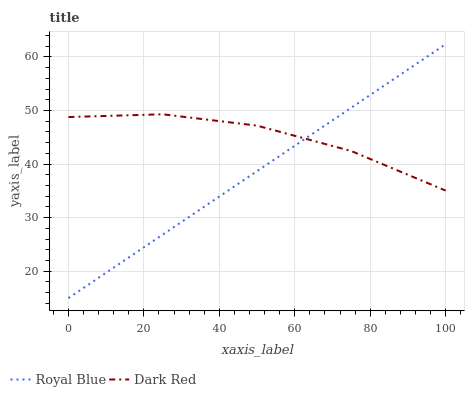Does Royal Blue have the minimum area under the curve?
Answer yes or no. Yes. Does Dark Red have the maximum area under the curve?
Answer yes or no. Yes. Does Dark Red have the minimum area under the curve?
Answer yes or no. No. Is Royal Blue the smoothest?
Answer yes or no. Yes. Is Dark Red the roughest?
Answer yes or no. Yes. Is Dark Red the smoothest?
Answer yes or no. No. Does Royal Blue have the lowest value?
Answer yes or no. Yes. Does Dark Red have the lowest value?
Answer yes or no. No. Does Royal Blue have the highest value?
Answer yes or no. Yes. Does Dark Red have the highest value?
Answer yes or no. No. Does Royal Blue intersect Dark Red?
Answer yes or no. Yes. Is Royal Blue less than Dark Red?
Answer yes or no. No. Is Royal Blue greater than Dark Red?
Answer yes or no. No. 